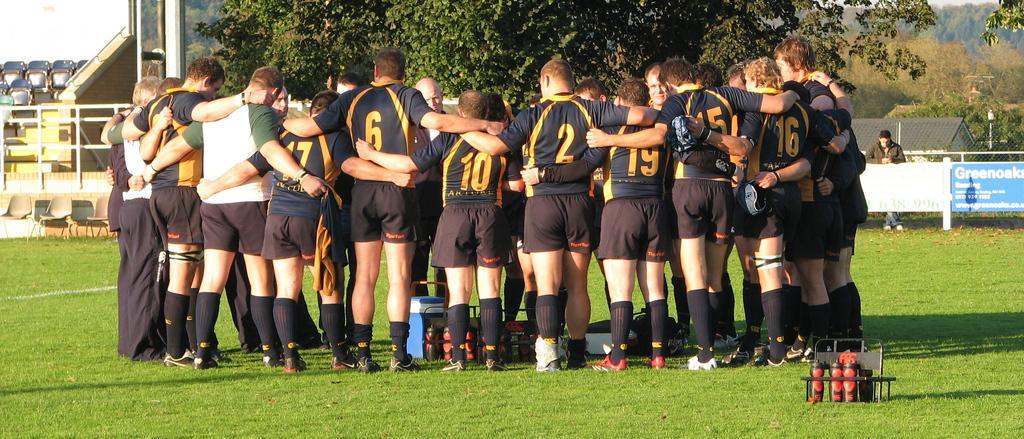How would you summarize this image in a sentence or two? In this picture I can see a group of people in the middle, in the background there are trees and chairs, on the right side there are advertisement boards and a house, I can see a person standing near the boards, at the bottom there are bottles in a stand. 